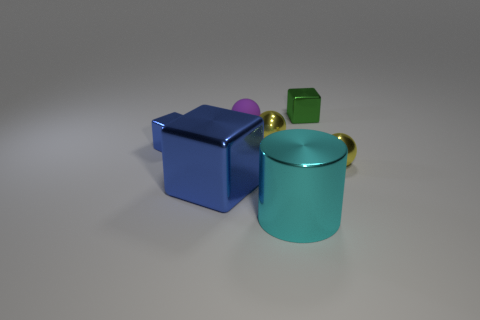What number of things are large metallic things that are behind the large cyan cylinder or things left of the small green shiny object?
Offer a terse response. 5. Are there more big metallic things that are on the right side of the small purple matte thing than big yellow cylinders?
Offer a terse response. Yes. What number of blue matte objects have the same size as the cyan cylinder?
Give a very brief answer. 0. There is a cube behind the small purple sphere; does it have the same size as the blue metallic thing in front of the small blue thing?
Give a very brief answer. No. There is a cyan cylinder to the left of the small green shiny thing; what size is it?
Make the answer very short. Large. How big is the blue metal cube that is in front of the yellow metal thing right of the green object?
Make the answer very short. Large. What is the material of the purple object that is the same size as the green cube?
Your answer should be compact. Rubber. Are there any big cubes in front of the big blue cube?
Offer a very short reply. No. Is the number of small green cubes that are on the left side of the small matte thing the same as the number of gray cylinders?
Make the answer very short. Yes. What is the shape of the green metallic thing that is the same size as the rubber object?
Your answer should be compact. Cube. 